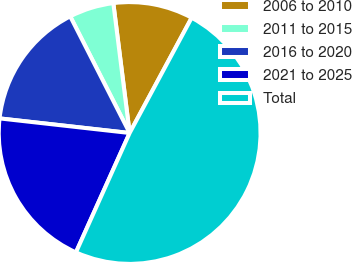<chart> <loc_0><loc_0><loc_500><loc_500><pie_chart><fcel>2006 to 2010<fcel>2011 to 2015<fcel>2016 to 2020<fcel>2021 to 2025<fcel>Total<nl><fcel>9.85%<fcel>5.51%<fcel>15.72%<fcel>20.05%<fcel>48.87%<nl></chart> 